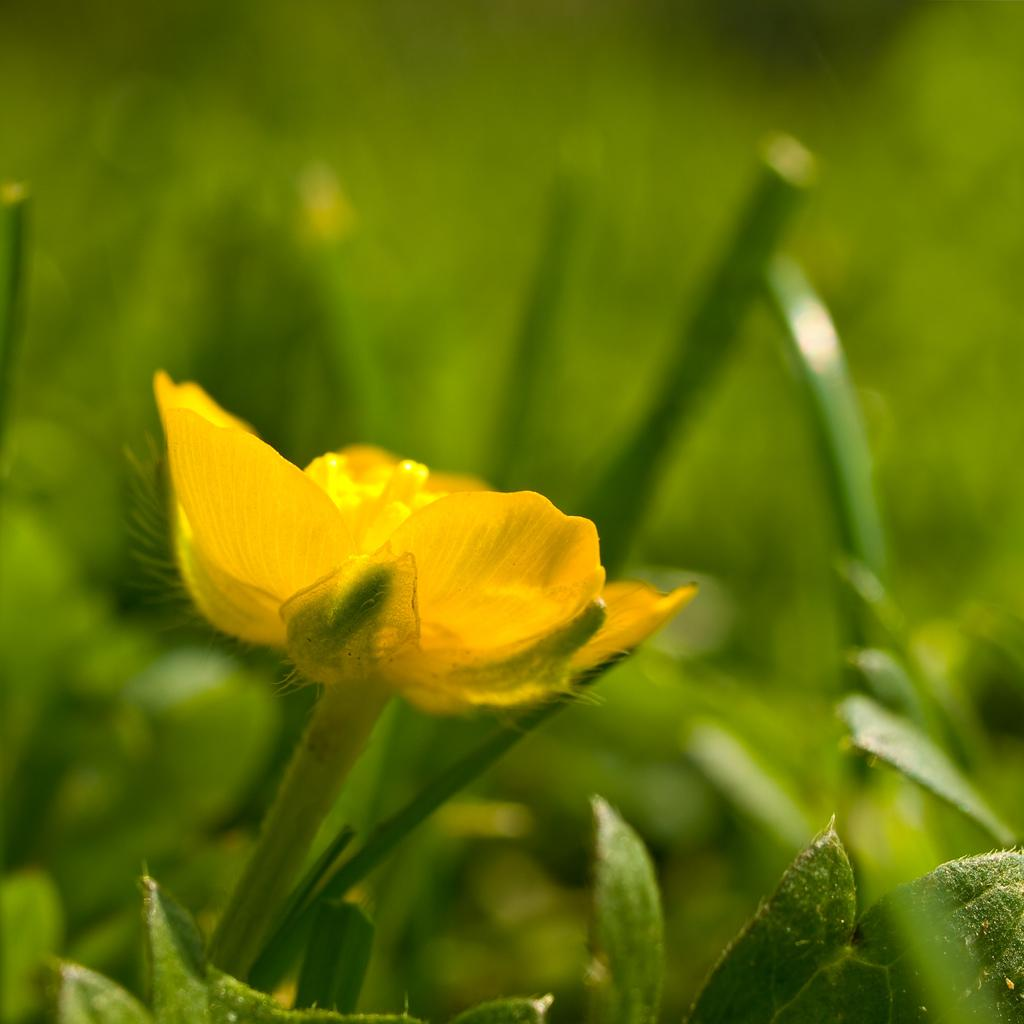What is the main subject of the image? There is a yellow flower in the middle of the image. What color are the leaves surrounding the flower? There are green leaves visible in the image. What type of government is depicted in the image? There is no depiction of a government in the image; it features a yellow flower and green leaves. Can you tell me how many frogs are sitting on the leaves in the image? There are no frogs present in the image. 